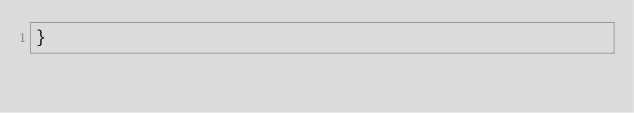<code> <loc_0><loc_0><loc_500><loc_500><_Kotlin_>}</code> 